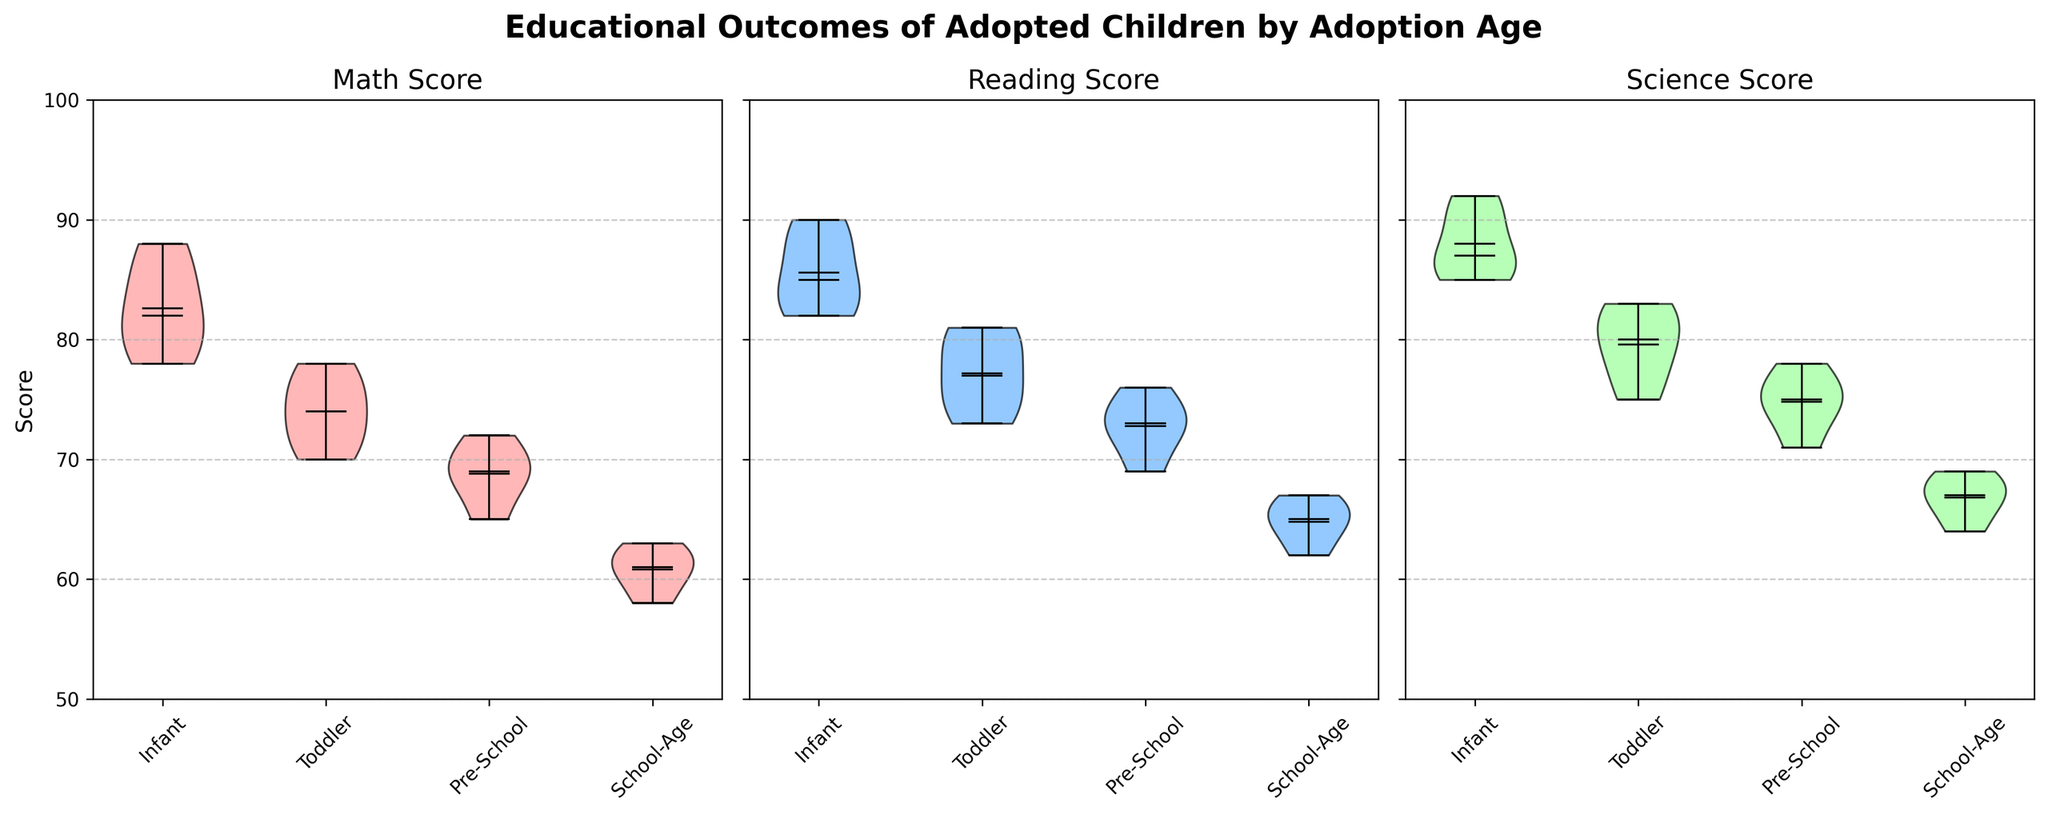What is the title of the figure? The title appears at the top of the figure. It reads "Educational Outcomes of Adopted Children by Adoption Age".
Answer: Educational Outcomes of Adopted Children by Adoption Age Which Adoption Age group has the highest median Reading Score? Look at the middle line within each violin plot for Reading Score across all Adoption Age groups. The longest middle line represents the highest median, which corresponds to the "Infant" group.
Answer: Infant Which subject's scores have the widest range across all Adoption Ages? Examine the spread of the violins across different subjects (Math, Reading, Science). The subject with the broadest range from top to bottom in any Adoption Age group indicates the widest range.
Answer: Science Do infants generally have higher Math Scores compared to school-aged children? Compare the position and size of the violin plots between the "Infant" and "School-Age" Math Score plots. If the "Infant" distribution is visually higher, it indicates higher scores.
Answer: Yes What is the mean Math Score for the Toddler group? The mean can be observed as the white dot in the middle of the violins. Identify the white dot for the "Toddler" group in the Math Score plot.
Answer: Approximately 74 Between which two Adoption Ages is the difference in median Science Scores the smallest? Check the middle lines of science scores for each Adoption Age. The smallest visual difference between middle lines indicates the smallest difference in median scores. Compare the differences.
Answer: Pre-School and School-Age Which subject shows the least variability in scores for the "Pre-School" group? Look at the "Pre-School" violin plots for all three subjects. The plot with the narrowest width indicates the least variability.
Answer: Reading How do the College Enrollment rates compare between adoption age groups? Check the College Enrollment distribution along the x-axis. Identify if the distributions show higher values for some specific Adoption Ages.
Answer: Higher in Infants Which subject shows a consistent decrease in scores from Infants to School-Age children? Compare the general trend of the violins for each subject from "Infant" to "School-Age". Look for a consistent downward movement.
Answer: Math 